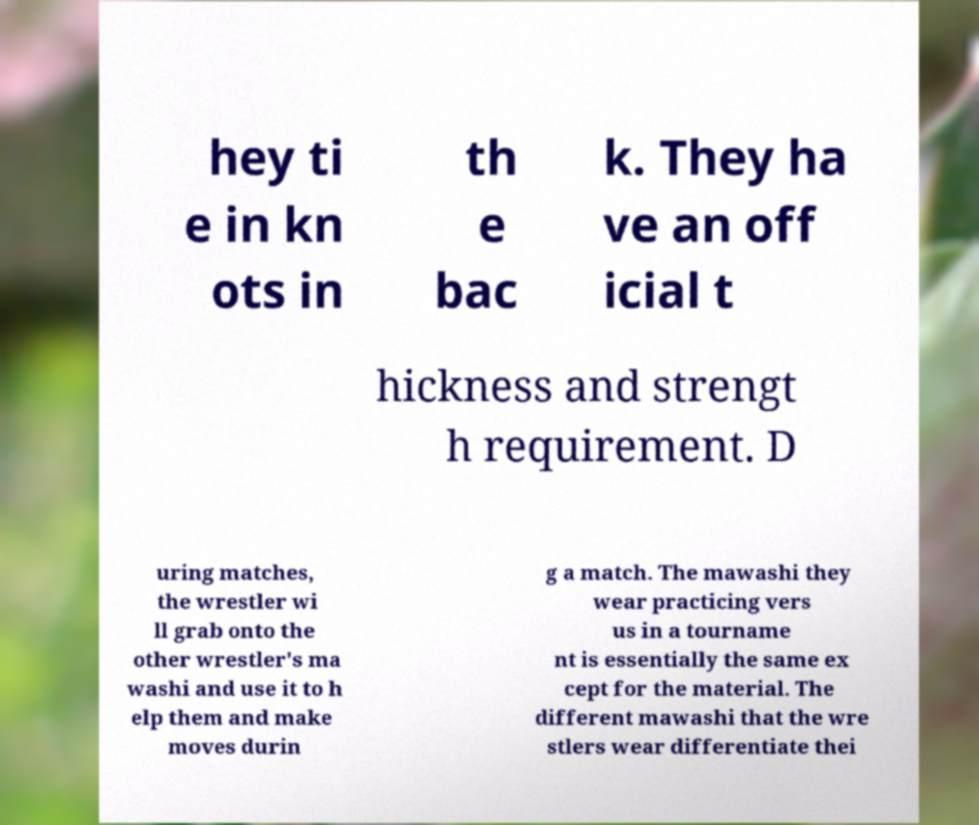Please read and relay the text visible in this image. What does it say? hey ti e in kn ots in th e bac k. They ha ve an off icial t hickness and strengt h requirement. D uring matches, the wrestler wi ll grab onto the other wrestler's ma washi and use it to h elp them and make moves durin g a match. The mawashi they wear practicing vers us in a tourname nt is essentially the same ex cept for the material. The different mawashi that the wre stlers wear differentiate thei 